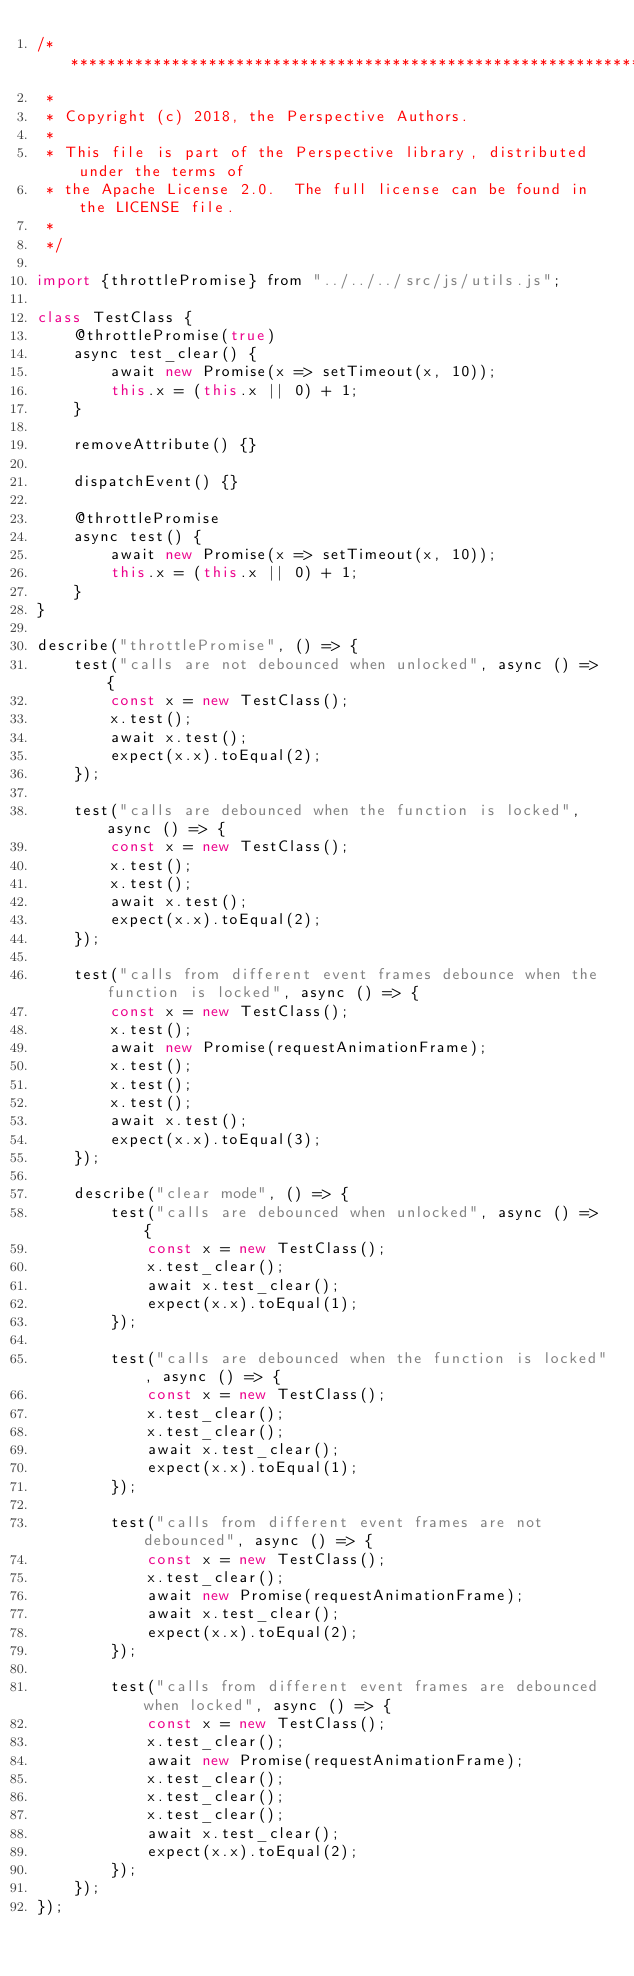<code> <loc_0><loc_0><loc_500><loc_500><_JavaScript_>/******************************************************************************
 *
 * Copyright (c) 2018, the Perspective Authors.
 *
 * This file is part of the Perspective library, distributed under the terms of
 * the Apache License 2.0.  The full license can be found in the LICENSE file.
 *
 */

import {throttlePromise} from "../../../src/js/utils.js";

class TestClass {
    @throttlePromise(true)
    async test_clear() {
        await new Promise(x => setTimeout(x, 10));
        this.x = (this.x || 0) + 1;
    }

    removeAttribute() {}

    dispatchEvent() {}

    @throttlePromise
    async test() {
        await new Promise(x => setTimeout(x, 10));
        this.x = (this.x || 0) + 1;
    }
}

describe("throttlePromise", () => {
    test("calls are not debounced when unlocked", async () => {
        const x = new TestClass();
        x.test();
        await x.test();
        expect(x.x).toEqual(2);
    });

    test("calls are debounced when the function is locked", async () => {
        const x = new TestClass();
        x.test();
        x.test();
        await x.test();
        expect(x.x).toEqual(2);
    });

    test("calls from different event frames debounce when the function is locked", async () => {
        const x = new TestClass();
        x.test();
        await new Promise(requestAnimationFrame);
        x.test();
        x.test();
        x.test();
        await x.test();
        expect(x.x).toEqual(3);
    });

    describe("clear mode", () => {
        test("calls are debounced when unlocked", async () => {
            const x = new TestClass();
            x.test_clear();
            await x.test_clear();
            expect(x.x).toEqual(1);
        });

        test("calls are debounced when the function is locked", async () => {
            const x = new TestClass();
            x.test_clear();
            x.test_clear();
            await x.test_clear();
            expect(x.x).toEqual(1);
        });

        test("calls from different event frames are not debounced", async () => {
            const x = new TestClass();
            x.test_clear();
            await new Promise(requestAnimationFrame);
            await x.test_clear();
            expect(x.x).toEqual(2);
        });

        test("calls from different event frames are debounced when locked", async () => {
            const x = new TestClass();
            x.test_clear();
            await new Promise(requestAnimationFrame);
            x.test_clear();
            x.test_clear();
            x.test_clear();
            await x.test_clear();
            expect(x.x).toEqual(2);
        });
    });
});
</code> 